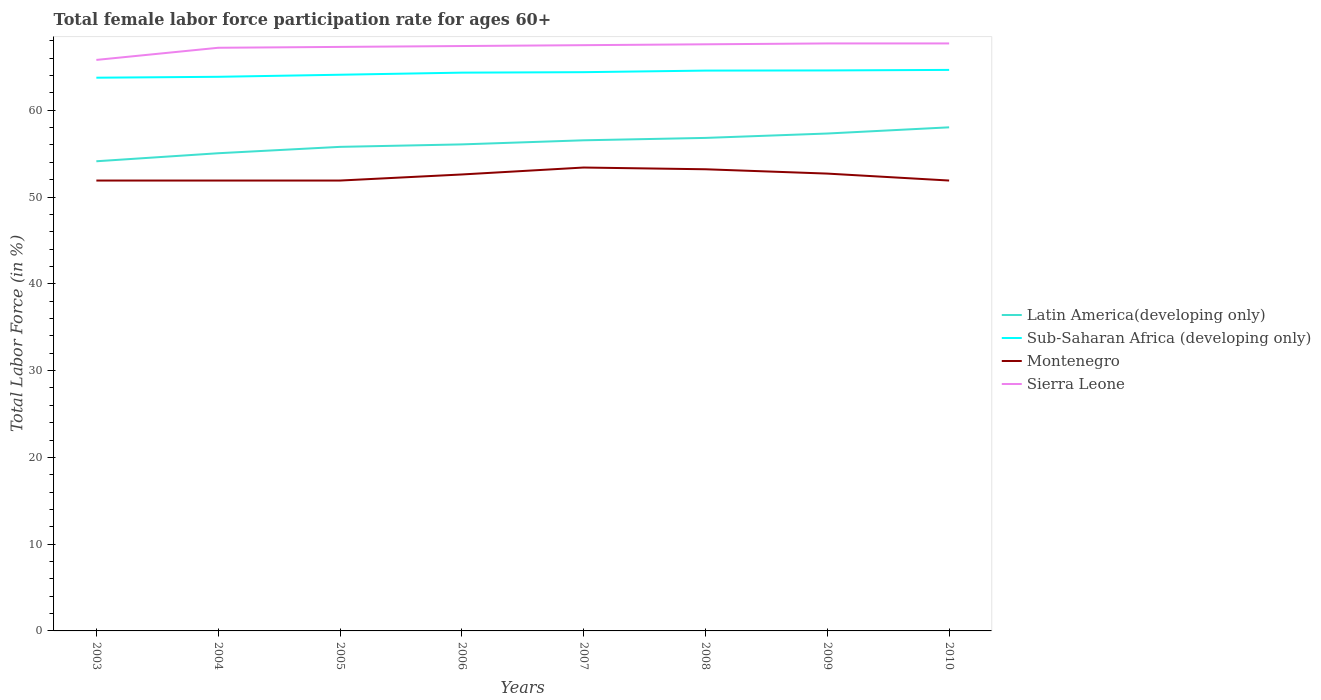How many different coloured lines are there?
Keep it short and to the point. 4. Does the line corresponding to Sierra Leone intersect with the line corresponding to Latin America(developing only)?
Your answer should be very brief. No. Across all years, what is the maximum female labor force participation rate in Latin America(developing only)?
Ensure brevity in your answer.  54.12. In which year was the female labor force participation rate in Montenegro maximum?
Offer a very short reply. 2003. What is the total female labor force participation rate in Latin America(developing only) in the graph?
Provide a short and direct response. -3.2. What is the difference between the highest and the second highest female labor force participation rate in Latin America(developing only)?
Your response must be concise. 3.91. What is the difference between the highest and the lowest female labor force participation rate in Latin America(developing only)?
Make the answer very short. 4. Is the female labor force participation rate in Latin America(developing only) strictly greater than the female labor force participation rate in Montenegro over the years?
Give a very brief answer. No. How many lines are there?
Provide a short and direct response. 4. How many years are there in the graph?
Ensure brevity in your answer.  8. What is the difference between two consecutive major ticks on the Y-axis?
Keep it short and to the point. 10. Where does the legend appear in the graph?
Offer a terse response. Center right. What is the title of the graph?
Provide a succinct answer. Total female labor force participation rate for ages 60+. What is the label or title of the Y-axis?
Keep it short and to the point. Total Labor Force (in %). What is the Total Labor Force (in %) of Latin America(developing only) in 2003?
Offer a terse response. 54.12. What is the Total Labor Force (in %) of Sub-Saharan Africa (developing only) in 2003?
Provide a succinct answer. 63.75. What is the Total Labor Force (in %) of Montenegro in 2003?
Your answer should be very brief. 51.9. What is the Total Labor Force (in %) in Sierra Leone in 2003?
Provide a short and direct response. 65.8. What is the Total Labor Force (in %) in Latin America(developing only) in 2004?
Your answer should be compact. 55.05. What is the Total Labor Force (in %) in Sub-Saharan Africa (developing only) in 2004?
Ensure brevity in your answer.  63.86. What is the Total Labor Force (in %) of Montenegro in 2004?
Your response must be concise. 51.9. What is the Total Labor Force (in %) of Sierra Leone in 2004?
Ensure brevity in your answer.  67.2. What is the Total Labor Force (in %) of Latin America(developing only) in 2005?
Provide a short and direct response. 55.78. What is the Total Labor Force (in %) of Sub-Saharan Africa (developing only) in 2005?
Offer a terse response. 64.09. What is the Total Labor Force (in %) of Montenegro in 2005?
Provide a succinct answer. 51.9. What is the Total Labor Force (in %) of Sierra Leone in 2005?
Ensure brevity in your answer.  67.3. What is the Total Labor Force (in %) in Latin America(developing only) in 2006?
Your answer should be very brief. 56.07. What is the Total Labor Force (in %) of Sub-Saharan Africa (developing only) in 2006?
Provide a short and direct response. 64.33. What is the Total Labor Force (in %) of Montenegro in 2006?
Your response must be concise. 52.6. What is the Total Labor Force (in %) of Sierra Leone in 2006?
Offer a very short reply. 67.4. What is the Total Labor Force (in %) in Latin America(developing only) in 2007?
Provide a succinct answer. 56.54. What is the Total Labor Force (in %) in Sub-Saharan Africa (developing only) in 2007?
Your answer should be very brief. 64.39. What is the Total Labor Force (in %) of Montenegro in 2007?
Give a very brief answer. 53.4. What is the Total Labor Force (in %) in Sierra Leone in 2007?
Your response must be concise. 67.5. What is the Total Labor Force (in %) in Latin America(developing only) in 2008?
Keep it short and to the point. 56.81. What is the Total Labor Force (in %) in Sub-Saharan Africa (developing only) in 2008?
Ensure brevity in your answer.  64.57. What is the Total Labor Force (in %) in Montenegro in 2008?
Ensure brevity in your answer.  53.2. What is the Total Labor Force (in %) in Sierra Leone in 2008?
Give a very brief answer. 67.6. What is the Total Labor Force (in %) in Latin America(developing only) in 2009?
Ensure brevity in your answer.  57.32. What is the Total Labor Force (in %) of Sub-Saharan Africa (developing only) in 2009?
Your answer should be compact. 64.59. What is the Total Labor Force (in %) of Montenegro in 2009?
Provide a short and direct response. 52.7. What is the Total Labor Force (in %) of Sierra Leone in 2009?
Your answer should be compact. 67.7. What is the Total Labor Force (in %) of Latin America(developing only) in 2010?
Make the answer very short. 58.03. What is the Total Labor Force (in %) of Sub-Saharan Africa (developing only) in 2010?
Ensure brevity in your answer.  64.65. What is the Total Labor Force (in %) in Montenegro in 2010?
Ensure brevity in your answer.  51.9. What is the Total Labor Force (in %) in Sierra Leone in 2010?
Your answer should be compact. 67.7. Across all years, what is the maximum Total Labor Force (in %) of Latin America(developing only)?
Provide a succinct answer. 58.03. Across all years, what is the maximum Total Labor Force (in %) in Sub-Saharan Africa (developing only)?
Provide a succinct answer. 64.65. Across all years, what is the maximum Total Labor Force (in %) of Montenegro?
Provide a succinct answer. 53.4. Across all years, what is the maximum Total Labor Force (in %) of Sierra Leone?
Your answer should be very brief. 67.7. Across all years, what is the minimum Total Labor Force (in %) of Latin America(developing only)?
Provide a succinct answer. 54.12. Across all years, what is the minimum Total Labor Force (in %) in Sub-Saharan Africa (developing only)?
Make the answer very short. 63.75. Across all years, what is the minimum Total Labor Force (in %) of Montenegro?
Offer a very short reply. 51.9. Across all years, what is the minimum Total Labor Force (in %) of Sierra Leone?
Provide a succinct answer. 65.8. What is the total Total Labor Force (in %) of Latin America(developing only) in the graph?
Ensure brevity in your answer.  449.71. What is the total Total Labor Force (in %) in Sub-Saharan Africa (developing only) in the graph?
Offer a terse response. 514.23. What is the total Total Labor Force (in %) of Montenegro in the graph?
Ensure brevity in your answer.  419.5. What is the total Total Labor Force (in %) in Sierra Leone in the graph?
Your answer should be very brief. 538.2. What is the difference between the Total Labor Force (in %) of Latin America(developing only) in 2003 and that in 2004?
Your response must be concise. -0.93. What is the difference between the Total Labor Force (in %) of Sub-Saharan Africa (developing only) in 2003 and that in 2004?
Ensure brevity in your answer.  -0.1. What is the difference between the Total Labor Force (in %) of Montenegro in 2003 and that in 2004?
Give a very brief answer. 0. What is the difference between the Total Labor Force (in %) of Latin America(developing only) in 2003 and that in 2005?
Your answer should be very brief. -1.66. What is the difference between the Total Labor Force (in %) in Sub-Saharan Africa (developing only) in 2003 and that in 2005?
Provide a short and direct response. -0.34. What is the difference between the Total Labor Force (in %) in Montenegro in 2003 and that in 2005?
Keep it short and to the point. 0. What is the difference between the Total Labor Force (in %) of Latin America(developing only) in 2003 and that in 2006?
Your answer should be very brief. -1.94. What is the difference between the Total Labor Force (in %) in Sub-Saharan Africa (developing only) in 2003 and that in 2006?
Make the answer very short. -0.58. What is the difference between the Total Labor Force (in %) of Montenegro in 2003 and that in 2006?
Keep it short and to the point. -0.7. What is the difference between the Total Labor Force (in %) in Latin America(developing only) in 2003 and that in 2007?
Offer a very short reply. -2.42. What is the difference between the Total Labor Force (in %) of Sub-Saharan Africa (developing only) in 2003 and that in 2007?
Your response must be concise. -0.64. What is the difference between the Total Labor Force (in %) in Montenegro in 2003 and that in 2007?
Your response must be concise. -1.5. What is the difference between the Total Labor Force (in %) in Latin America(developing only) in 2003 and that in 2008?
Your response must be concise. -2.69. What is the difference between the Total Labor Force (in %) in Sub-Saharan Africa (developing only) in 2003 and that in 2008?
Keep it short and to the point. -0.82. What is the difference between the Total Labor Force (in %) of Sierra Leone in 2003 and that in 2008?
Keep it short and to the point. -1.8. What is the difference between the Total Labor Force (in %) in Latin America(developing only) in 2003 and that in 2009?
Give a very brief answer. -3.2. What is the difference between the Total Labor Force (in %) in Sub-Saharan Africa (developing only) in 2003 and that in 2009?
Keep it short and to the point. -0.84. What is the difference between the Total Labor Force (in %) of Montenegro in 2003 and that in 2009?
Provide a short and direct response. -0.8. What is the difference between the Total Labor Force (in %) in Sierra Leone in 2003 and that in 2009?
Ensure brevity in your answer.  -1.9. What is the difference between the Total Labor Force (in %) of Latin America(developing only) in 2003 and that in 2010?
Provide a short and direct response. -3.91. What is the difference between the Total Labor Force (in %) in Sub-Saharan Africa (developing only) in 2003 and that in 2010?
Your answer should be very brief. -0.9. What is the difference between the Total Labor Force (in %) in Latin America(developing only) in 2004 and that in 2005?
Your answer should be very brief. -0.73. What is the difference between the Total Labor Force (in %) of Sub-Saharan Africa (developing only) in 2004 and that in 2005?
Offer a very short reply. -0.24. What is the difference between the Total Labor Force (in %) of Latin America(developing only) in 2004 and that in 2006?
Make the answer very short. -1.02. What is the difference between the Total Labor Force (in %) of Sub-Saharan Africa (developing only) in 2004 and that in 2006?
Provide a short and direct response. -0.48. What is the difference between the Total Labor Force (in %) in Latin America(developing only) in 2004 and that in 2007?
Ensure brevity in your answer.  -1.49. What is the difference between the Total Labor Force (in %) in Sub-Saharan Africa (developing only) in 2004 and that in 2007?
Your response must be concise. -0.53. What is the difference between the Total Labor Force (in %) in Latin America(developing only) in 2004 and that in 2008?
Your response must be concise. -1.77. What is the difference between the Total Labor Force (in %) of Sub-Saharan Africa (developing only) in 2004 and that in 2008?
Your answer should be very brief. -0.71. What is the difference between the Total Labor Force (in %) in Latin America(developing only) in 2004 and that in 2009?
Provide a succinct answer. -2.27. What is the difference between the Total Labor Force (in %) of Sub-Saharan Africa (developing only) in 2004 and that in 2009?
Give a very brief answer. -0.73. What is the difference between the Total Labor Force (in %) of Montenegro in 2004 and that in 2009?
Keep it short and to the point. -0.8. What is the difference between the Total Labor Force (in %) in Sierra Leone in 2004 and that in 2009?
Your answer should be compact. -0.5. What is the difference between the Total Labor Force (in %) of Latin America(developing only) in 2004 and that in 2010?
Provide a succinct answer. -2.99. What is the difference between the Total Labor Force (in %) in Sub-Saharan Africa (developing only) in 2004 and that in 2010?
Ensure brevity in your answer.  -0.79. What is the difference between the Total Labor Force (in %) of Latin America(developing only) in 2005 and that in 2006?
Provide a short and direct response. -0.28. What is the difference between the Total Labor Force (in %) in Sub-Saharan Africa (developing only) in 2005 and that in 2006?
Your answer should be very brief. -0.24. What is the difference between the Total Labor Force (in %) of Sierra Leone in 2005 and that in 2006?
Provide a succinct answer. -0.1. What is the difference between the Total Labor Force (in %) of Latin America(developing only) in 2005 and that in 2007?
Give a very brief answer. -0.76. What is the difference between the Total Labor Force (in %) in Sub-Saharan Africa (developing only) in 2005 and that in 2007?
Your answer should be compact. -0.3. What is the difference between the Total Labor Force (in %) of Latin America(developing only) in 2005 and that in 2008?
Your answer should be compact. -1.03. What is the difference between the Total Labor Force (in %) of Sub-Saharan Africa (developing only) in 2005 and that in 2008?
Provide a short and direct response. -0.48. What is the difference between the Total Labor Force (in %) in Latin America(developing only) in 2005 and that in 2009?
Keep it short and to the point. -1.54. What is the difference between the Total Labor Force (in %) of Sub-Saharan Africa (developing only) in 2005 and that in 2009?
Provide a succinct answer. -0.49. What is the difference between the Total Labor Force (in %) in Montenegro in 2005 and that in 2009?
Provide a short and direct response. -0.8. What is the difference between the Total Labor Force (in %) in Latin America(developing only) in 2005 and that in 2010?
Provide a short and direct response. -2.25. What is the difference between the Total Labor Force (in %) in Sub-Saharan Africa (developing only) in 2005 and that in 2010?
Your answer should be compact. -0.56. What is the difference between the Total Labor Force (in %) in Sierra Leone in 2005 and that in 2010?
Keep it short and to the point. -0.4. What is the difference between the Total Labor Force (in %) of Latin America(developing only) in 2006 and that in 2007?
Give a very brief answer. -0.47. What is the difference between the Total Labor Force (in %) of Sub-Saharan Africa (developing only) in 2006 and that in 2007?
Your response must be concise. -0.06. What is the difference between the Total Labor Force (in %) of Sierra Leone in 2006 and that in 2007?
Keep it short and to the point. -0.1. What is the difference between the Total Labor Force (in %) of Latin America(developing only) in 2006 and that in 2008?
Your response must be concise. -0.75. What is the difference between the Total Labor Force (in %) of Sub-Saharan Africa (developing only) in 2006 and that in 2008?
Your response must be concise. -0.24. What is the difference between the Total Labor Force (in %) in Montenegro in 2006 and that in 2008?
Keep it short and to the point. -0.6. What is the difference between the Total Labor Force (in %) in Sierra Leone in 2006 and that in 2008?
Provide a short and direct response. -0.2. What is the difference between the Total Labor Force (in %) in Latin America(developing only) in 2006 and that in 2009?
Your answer should be very brief. -1.25. What is the difference between the Total Labor Force (in %) in Sub-Saharan Africa (developing only) in 2006 and that in 2009?
Provide a succinct answer. -0.25. What is the difference between the Total Labor Force (in %) of Montenegro in 2006 and that in 2009?
Your answer should be compact. -0.1. What is the difference between the Total Labor Force (in %) of Latin America(developing only) in 2006 and that in 2010?
Offer a terse response. -1.97. What is the difference between the Total Labor Force (in %) of Sub-Saharan Africa (developing only) in 2006 and that in 2010?
Your response must be concise. -0.32. What is the difference between the Total Labor Force (in %) of Montenegro in 2006 and that in 2010?
Keep it short and to the point. 0.7. What is the difference between the Total Labor Force (in %) in Latin America(developing only) in 2007 and that in 2008?
Offer a terse response. -0.28. What is the difference between the Total Labor Force (in %) in Sub-Saharan Africa (developing only) in 2007 and that in 2008?
Offer a terse response. -0.18. What is the difference between the Total Labor Force (in %) of Sierra Leone in 2007 and that in 2008?
Give a very brief answer. -0.1. What is the difference between the Total Labor Force (in %) in Latin America(developing only) in 2007 and that in 2009?
Give a very brief answer. -0.78. What is the difference between the Total Labor Force (in %) in Sub-Saharan Africa (developing only) in 2007 and that in 2009?
Provide a succinct answer. -0.2. What is the difference between the Total Labor Force (in %) of Montenegro in 2007 and that in 2009?
Provide a succinct answer. 0.7. What is the difference between the Total Labor Force (in %) of Sierra Leone in 2007 and that in 2009?
Your answer should be compact. -0.2. What is the difference between the Total Labor Force (in %) of Latin America(developing only) in 2007 and that in 2010?
Your answer should be compact. -1.49. What is the difference between the Total Labor Force (in %) in Sub-Saharan Africa (developing only) in 2007 and that in 2010?
Your answer should be compact. -0.26. What is the difference between the Total Labor Force (in %) in Montenegro in 2007 and that in 2010?
Your response must be concise. 1.5. What is the difference between the Total Labor Force (in %) in Latin America(developing only) in 2008 and that in 2009?
Your response must be concise. -0.51. What is the difference between the Total Labor Force (in %) in Sub-Saharan Africa (developing only) in 2008 and that in 2009?
Keep it short and to the point. -0.02. What is the difference between the Total Labor Force (in %) of Montenegro in 2008 and that in 2009?
Give a very brief answer. 0.5. What is the difference between the Total Labor Force (in %) of Latin America(developing only) in 2008 and that in 2010?
Provide a succinct answer. -1.22. What is the difference between the Total Labor Force (in %) of Sub-Saharan Africa (developing only) in 2008 and that in 2010?
Offer a terse response. -0.08. What is the difference between the Total Labor Force (in %) of Sierra Leone in 2008 and that in 2010?
Provide a succinct answer. -0.1. What is the difference between the Total Labor Force (in %) in Latin America(developing only) in 2009 and that in 2010?
Make the answer very short. -0.71. What is the difference between the Total Labor Force (in %) in Sub-Saharan Africa (developing only) in 2009 and that in 2010?
Your answer should be compact. -0.06. What is the difference between the Total Labor Force (in %) of Sierra Leone in 2009 and that in 2010?
Give a very brief answer. 0. What is the difference between the Total Labor Force (in %) in Latin America(developing only) in 2003 and the Total Labor Force (in %) in Sub-Saharan Africa (developing only) in 2004?
Give a very brief answer. -9.73. What is the difference between the Total Labor Force (in %) in Latin America(developing only) in 2003 and the Total Labor Force (in %) in Montenegro in 2004?
Ensure brevity in your answer.  2.22. What is the difference between the Total Labor Force (in %) of Latin America(developing only) in 2003 and the Total Labor Force (in %) of Sierra Leone in 2004?
Offer a terse response. -13.08. What is the difference between the Total Labor Force (in %) in Sub-Saharan Africa (developing only) in 2003 and the Total Labor Force (in %) in Montenegro in 2004?
Your answer should be compact. 11.85. What is the difference between the Total Labor Force (in %) of Sub-Saharan Africa (developing only) in 2003 and the Total Labor Force (in %) of Sierra Leone in 2004?
Provide a short and direct response. -3.45. What is the difference between the Total Labor Force (in %) of Montenegro in 2003 and the Total Labor Force (in %) of Sierra Leone in 2004?
Provide a short and direct response. -15.3. What is the difference between the Total Labor Force (in %) in Latin America(developing only) in 2003 and the Total Labor Force (in %) in Sub-Saharan Africa (developing only) in 2005?
Your answer should be compact. -9.97. What is the difference between the Total Labor Force (in %) of Latin America(developing only) in 2003 and the Total Labor Force (in %) of Montenegro in 2005?
Make the answer very short. 2.22. What is the difference between the Total Labor Force (in %) in Latin America(developing only) in 2003 and the Total Labor Force (in %) in Sierra Leone in 2005?
Your answer should be very brief. -13.18. What is the difference between the Total Labor Force (in %) of Sub-Saharan Africa (developing only) in 2003 and the Total Labor Force (in %) of Montenegro in 2005?
Your answer should be compact. 11.85. What is the difference between the Total Labor Force (in %) in Sub-Saharan Africa (developing only) in 2003 and the Total Labor Force (in %) in Sierra Leone in 2005?
Make the answer very short. -3.55. What is the difference between the Total Labor Force (in %) of Montenegro in 2003 and the Total Labor Force (in %) of Sierra Leone in 2005?
Ensure brevity in your answer.  -15.4. What is the difference between the Total Labor Force (in %) of Latin America(developing only) in 2003 and the Total Labor Force (in %) of Sub-Saharan Africa (developing only) in 2006?
Make the answer very short. -10.21. What is the difference between the Total Labor Force (in %) of Latin America(developing only) in 2003 and the Total Labor Force (in %) of Montenegro in 2006?
Offer a very short reply. 1.52. What is the difference between the Total Labor Force (in %) in Latin America(developing only) in 2003 and the Total Labor Force (in %) in Sierra Leone in 2006?
Offer a terse response. -13.28. What is the difference between the Total Labor Force (in %) in Sub-Saharan Africa (developing only) in 2003 and the Total Labor Force (in %) in Montenegro in 2006?
Your answer should be compact. 11.15. What is the difference between the Total Labor Force (in %) in Sub-Saharan Africa (developing only) in 2003 and the Total Labor Force (in %) in Sierra Leone in 2006?
Ensure brevity in your answer.  -3.65. What is the difference between the Total Labor Force (in %) in Montenegro in 2003 and the Total Labor Force (in %) in Sierra Leone in 2006?
Make the answer very short. -15.5. What is the difference between the Total Labor Force (in %) of Latin America(developing only) in 2003 and the Total Labor Force (in %) of Sub-Saharan Africa (developing only) in 2007?
Offer a terse response. -10.27. What is the difference between the Total Labor Force (in %) in Latin America(developing only) in 2003 and the Total Labor Force (in %) in Montenegro in 2007?
Your answer should be very brief. 0.72. What is the difference between the Total Labor Force (in %) of Latin America(developing only) in 2003 and the Total Labor Force (in %) of Sierra Leone in 2007?
Make the answer very short. -13.38. What is the difference between the Total Labor Force (in %) in Sub-Saharan Africa (developing only) in 2003 and the Total Labor Force (in %) in Montenegro in 2007?
Your answer should be very brief. 10.35. What is the difference between the Total Labor Force (in %) of Sub-Saharan Africa (developing only) in 2003 and the Total Labor Force (in %) of Sierra Leone in 2007?
Offer a terse response. -3.75. What is the difference between the Total Labor Force (in %) of Montenegro in 2003 and the Total Labor Force (in %) of Sierra Leone in 2007?
Your answer should be compact. -15.6. What is the difference between the Total Labor Force (in %) in Latin America(developing only) in 2003 and the Total Labor Force (in %) in Sub-Saharan Africa (developing only) in 2008?
Your answer should be compact. -10.45. What is the difference between the Total Labor Force (in %) in Latin America(developing only) in 2003 and the Total Labor Force (in %) in Montenegro in 2008?
Keep it short and to the point. 0.92. What is the difference between the Total Labor Force (in %) in Latin America(developing only) in 2003 and the Total Labor Force (in %) in Sierra Leone in 2008?
Your response must be concise. -13.48. What is the difference between the Total Labor Force (in %) of Sub-Saharan Africa (developing only) in 2003 and the Total Labor Force (in %) of Montenegro in 2008?
Make the answer very short. 10.55. What is the difference between the Total Labor Force (in %) in Sub-Saharan Africa (developing only) in 2003 and the Total Labor Force (in %) in Sierra Leone in 2008?
Your response must be concise. -3.85. What is the difference between the Total Labor Force (in %) in Montenegro in 2003 and the Total Labor Force (in %) in Sierra Leone in 2008?
Provide a succinct answer. -15.7. What is the difference between the Total Labor Force (in %) in Latin America(developing only) in 2003 and the Total Labor Force (in %) in Sub-Saharan Africa (developing only) in 2009?
Offer a terse response. -10.47. What is the difference between the Total Labor Force (in %) in Latin America(developing only) in 2003 and the Total Labor Force (in %) in Montenegro in 2009?
Offer a terse response. 1.42. What is the difference between the Total Labor Force (in %) of Latin America(developing only) in 2003 and the Total Labor Force (in %) of Sierra Leone in 2009?
Your response must be concise. -13.58. What is the difference between the Total Labor Force (in %) in Sub-Saharan Africa (developing only) in 2003 and the Total Labor Force (in %) in Montenegro in 2009?
Make the answer very short. 11.05. What is the difference between the Total Labor Force (in %) of Sub-Saharan Africa (developing only) in 2003 and the Total Labor Force (in %) of Sierra Leone in 2009?
Keep it short and to the point. -3.95. What is the difference between the Total Labor Force (in %) in Montenegro in 2003 and the Total Labor Force (in %) in Sierra Leone in 2009?
Make the answer very short. -15.8. What is the difference between the Total Labor Force (in %) of Latin America(developing only) in 2003 and the Total Labor Force (in %) of Sub-Saharan Africa (developing only) in 2010?
Make the answer very short. -10.53. What is the difference between the Total Labor Force (in %) in Latin America(developing only) in 2003 and the Total Labor Force (in %) in Montenegro in 2010?
Your answer should be very brief. 2.22. What is the difference between the Total Labor Force (in %) of Latin America(developing only) in 2003 and the Total Labor Force (in %) of Sierra Leone in 2010?
Offer a terse response. -13.58. What is the difference between the Total Labor Force (in %) of Sub-Saharan Africa (developing only) in 2003 and the Total Labor Force (in %) of Montenegro in 2010?
Keep it short and to the point. 11.85. What is the difference between the Total Labor Force (in %) in Sub-Saharan Africa (developing only) in 2003 and the Total Labor Force (in %) in Sierra Leone in 2010?
Offer a terse response. -3.95. What is the difference between the Total Labor Force (in %) in Montenegro in 2003 and the Total Labor Force (in %) in Sierra Leone in 2010?
Make the answer very short. -15.8. What is the difference between the Total Labor Force (in %) in Latin America(developing only) in 2004 and the Total Labor Force (in %) in Sub-Saharan Africa (developing only) in 2005?
Your response must be concise. -9.05. What is the difference between the Total Labor Force (in %) in Latin America(developing only) in 2004 and the Total Labor Force (in %) in Montenegro in 2005?
Give a very brief answer. 3.15. What is the difference between the Total Labor Force (in %) in Latin America(developing only) in 2004 and the Total Labor Force (in %) in Sierra Leone in 2005?
Your response must be concise. -12.25. What is the difference between the Total Labor Force (in %) of Sub-Saharan Africa (developing only) in 2004 and the Total Labor Force (in %) of Montenegro in 2005?
Offer a terse response. 11.96. What is the difference between the Total Labor Force (in %) in Sub-Saharan Africa (developing only) in 2004 and the Total Labor Force (in %) in Sierra Leone in 2005?
Ensure brevity in your answer.  -3.44. What is the difference between the Total Labor Force (in %) in Montenegro in 2004 and the Total Labor Force (in %) in Sierra Leone in 2005?
Make the answer very short. -15.4. What is the difference between the Total Labor Force (in %) in Latin America(developing only) in 2004 and the Total Labor Force (in %) in Sub-Saharan Africa (developing only) in 2006?
Your response must be concise. -9.29. What is the difference between the Total Labor Force (in %) in Latin America(developing only) in 2004 and the Total Labor Force (in %) in Montenegro in 2006?
Make the answer very short. 2.45. What is the difference between the Total Labor Force (in %) of Latin America(developing only) in 2004 and the Total Labor Force (in %) of Sierra Leone in 2006?
Provide a short and direct response. -12.35. What is the difference between the Total Labor Force (in %) in Sub-Saharan Africa (developing only) in 2004 and the Total Labor Force (in %) in Montenegro in 2006?
Make the answer very short. 11.26. What is the difference between the Total Labor Force (in %) of Sub-Saharan Africa (developing only) in 2004 and the Total Labor Force (in %) of Sierra Leone in 2006?
Provide a short and direct response. -3.54. What is the difference between the Total Labor Force (in %) in Montenegro in 2004 and the Total Labor Force (in %) in Sierra Leone in 2006?
Provide a succinct answer. -15.5. What is the difference between the Total Labor Force (in %) of Latin America(developing only) in 2004 and the Total Labor Force (in %) of Sub-Saharan Africa (developing only) in 2007?
Your answer should be very brief. -9.34. What is the difference between the Total Labor Force (in %) of Latin America(developing only) in 2004 and the Total Labor Force (in %) of Montenegro in 2007?
Your response must be concise. 1.65. What is the difference between the Total Labor Force (in %) in Latin America(developing only) in 2004 and the Total Labor Force (in %) in Sierra Leone in 2007?
Your answer should be very brief. -12.45. What is the difference between the Total Labor Force (in %) in Sub-Saharan Africa (developing only) in 2004 and the Total Labor Force (in %) in Montenegro in 2007?
Give a very brief answer. 10.46. What is the difference between the Total Labor Force (in %) of Sub-Saharan Africa (developing only) in 2004 and the Total Labor Force (in %) of Sierra Leone in 2007?
Give a very brief answer. -3.64. What is the difference between the Total Labor Force (in %) of Montenegro in 2004 and the Total Labor Force (in %) of Sierra Leone in 2007?
Provide a short and direct response. -15.6. What is the difference between the Total Labor Force (in %) of Latin America(developing only) in 2004 and the Total Labor Force (in %) of Sub-Saharan Africa (developing only) in 2008?
Make the answer very short. -9.52. What is the difference between the Total Labor Force (in %) of Latin America(developing only) in 2004 and the Total Labor Force (in %) of Montenegro in 2008?
Keep it short and to the point. 1.85. What is the difference between the Total Labor Force (in %) in Latin America(developing only) in 2004 and the Total Labor Force (in %) in Sierra Leone in 2008?
Ensure brevity in your answer.  -12.55. What is the difference between the Total Labor Force (in %) in Sub-Saharan Africa (developing only) in 2004 and the Total Labor Force (in %) in Montenegro in 2008?
Keep it short and to the point. 10.66. What is the difference between the Total Labor Force (in %) of Sub-Saharan Africa (developing only) in 2004 and the Total Labor Force (in %) of Sierra Leone in 2008?
Ensure brevity in your answer.  -3.74. What is the difference between the Total Labor Force (in %) in Montenegro in 2004 and the Total Labor Force (in %) in Sierra Leone in 2008?
Keep it short and to the point. -15.7. What is the difference between the Total Labor Force (in %) in Latin America(developing only) in 2004 and the Total Labor Force (in %) in Sub-Saharan Africa (developing only) in 2009?
Offer a terse response. -9.54. What is the difference between the Total Labor Force (in %) in Latin America(developing only) in 2004 and the Total Labor Force (in %) in Montenegro in 2009?
Offer a terse response. 2.35. What is the difference between the Total Labor Force (in %) in Latin America(developing only) in 2004 and the Total Labor Force (in %) in Sierra Leone in 2009?
Ensure brevity in your answer.  -12.65. What is the difference between the Total Labor Force (in %) in Sub-Saharan Africa (developing only) in 2004 and the Total Labor Force (in %) in Montenegro in 2009?
Provide a short and direct response. 11.16. What is the difference between the Total Labor Force (in %) of Sub-Saharan Africa (developing only) in 2004 and the Total Labor Force (in %) of Sierra Leone in 2009?
Keep it short and to the point. -3.84. What is the difference between the Total Labor Force (in %) of Montenegro in 2004 and the Total Labor Force (in %) of Sierra Leone in 2009?
Offer a terse response. -15.8. What is the difference between the Total Labor Force (in %) in Latin America(developing only) in 2004 and the Total Labor Force (in %) in Sub-Saharan Africa (developing only) in 2010?
Make the answer very short. -9.6. What is the difference between the Total Labor Force (in %) of Latin America(developing only) in 2004 and the Total Labor Force (in %) of Montenegro in 2010?
Provide a succinct answer. 3.15. What is the difference between the Total Labor Force (in %) of Latin America(developing only) in 2004 and the Total Labor Force (in %) of Sierra Leone in 2010?
Your response must be concise. -12.65. What is the difference between the Total Labor Force (in %) in Sub-Saharan Africa (developing only) in 2004 and the Total Labor Force (in %) in Montenegro in 2010?
Make the answer very short. 11.96. What is the difference between the Total Labor Force (in %) of Sub-Saharan Africa (developing only) in 2004 and the Total Labor Force (in %) of Sierra Leone in 2010?
Your answer should be very brief. -3.84. What is the difference between the Total Labor Force (in %) of Montenegro in 2004 and the Total Labor Force (in %) of Sierra Leone in 2010?
Give a very brief answer. -15.8. What is the difference between the Total Labor Force (in %) of Latin America(developing only) in 2005 and the Total Labor Force (in %) of Sub-Saharan Africa (developing only) in 2006?
Your answer should be compact. -8.55. What is the difference between the Total Labor Force (in %) of Latin America(developing only) in 2005 and the Total Labor Force (in %) of Montenegro in 2006?
Provide a succinct answer. 3.18. What is the difference between the Total Labor Force (in %) in Latin America(developing only) in 2005 and the Total Labor Force (in %) in Sierra Leone in 2006?
Your response must be concise. -11.62. What is the difference between the Total Labor Force (in %) of Sub-Saharan Africa (developing only) in 2005 and the Total Labor Force (in %) of Montenegro in 2006?
Your answer should be compact. 11.49. What is the difference between the Total Labor Force (in %) of Sub-Saharan Africa (developing only) in 2005 and the Total Labor Force (in %) of Sierra Leone in 2006?
Ensure brevity in your answer.  -3.31. What is the difference between the Total Labor Force (in %) in Montenegro in 2005 and the Total Labor Force (in %) in Sierra Leone in 2006?
Offer a terse response. -15.5. What is the difference between the Total Labor Force (in %) of Latin America(developing only) in 2005 and the Total Labor Force (in %) of Sub-Saharan Africa (developing only) in 2007?
Keep it short and to the point. -8.61. What is the difference between the Total Labor Force (in %) of Latin America(developing only) in 2005 and the Total Labor Force (in %) of Montenegro in 2007?
Give a very brief answer. 2.38. What is the difference between the Total Labor Force (in %) of Latin America(developing only) in 2005 and the Total Labor Force (in %) of Sierra Leone in 2007?
Give a very brief answer. -11.72. What is the difference between the Total Labor Force (in %) of Sub-Saharan Africa (developing only) in 2005 and the Total Labor Force (in %) of Montenegro in 2007?
Your answer should be compact. 10.69. What is the difference between the Total Labor Force (in %) in Sub-Saharan Africa (developing only) in 2005 and the Total Labor Force (in %) in Sierra Leone in 2007?
Ensure brevity in your answer.  -3.41. What is the difference between the Total Labor Force (in %) of Montenegro in 2005 and the Total Labor Force (in %) of Sierra Leone in 2007?
Keep it short and to the point. -15.6. What is the difference between the Total Labor Force (in %) in Latin America(developing only) in 2005 and the Total Labor Force (in %) in Sub-Saharan Africa (developing only) in 2008?
Provide a short and direct response. -8.79. What is the difference between the Total Labor Force (in %) in Latin America(developing only) in 2005 and the Total Labor Force (in %) in Montenegro in 2008?
Provide a succinct answer. 2.58. What is the difference between the Total Labor Force (in %) of Latin America(developing only) in 2005 and the Total Labor Force (in %) of Sierra Leone in 2008?
Ensure brevity in your answer.  -11.82. What is the difference between the Total Labor Force (in %) in Sub-Saharan Africa (developing only) in 2005 and the Total Labor Force (in %) in Montenegro in 2008?
Ensure brevity in your answer.  10.89. What is the difference between the Total Labor Force (in %) in Sub-Saharan Africa (developing only) in 2005 and the Total Labor Force (in %) in Sierra Leone in 2008?
Your answer should be very brief. -3.51. What is the difference between the Total Labor Force (in %) of Montenegro in 2005 and the Total Labor Force (in %) of Sierra Leone in 2008?
Make the answer very short. -15.7. What is the difference between the Total Labor Force (in %) of Latin America(developing only) in 2005 and the Total Labor Force (in %) of Sub-Saharan Africa (developing only) in 2009?
Provide a succinct answer. -8.81. What is the difference between the Total Labor Force (in %) of Latin America(developing only) in 2005 and the Total Labor Force (in %) of Montenegro in 2009?
Provide a succinct answer. 3.08. What is the difference between the Total Labor Force (in %) in Latin America(developing only) in 2005 and the Total Labor Force (in %) in Sierra Leone in 2009?
Your answer should be compact. -11.92. What is the difference between the Total Labor Force (in %) in Sub-Saharan Africa (developing only) in 2005 and the Total Labor Force (in %) in Montenegro in 2009?
Provide a short and direct response. 11.39. What is the difference between the Total Labor Force (in %) of Sub-Saharan Africa (developing only) in 2005 and the Total Labor Force (in %) of Sierra Leone in 2009?
Your answer should be compact. -3.61. What is the difference between the Total Labor Force (in %) in Montenegro in 2005 and the Total Labor Force (in %) in Sierra Leone in 2009?
Give a very brief answer. -15.8. What is the difference between the Total Labor Force (in %) of Latin America(developing only) in 2005 and the Total Labor Force (in %) of Sub-Saharan Africa (developing only) in 2010?
Your answer should be compact. -8.87. What is the difference between the Total Labor Force (in %) of Latin America(developing only) in 2005 and the Total Labor Force (in %) of Montenegro in 2010?
Give a very brief answer. 3.88. What is the difference between the Total Labor Force (in %) in Latin America(developing only) in 2005 and the Total Labor Force (in %) in Sierra Leone in 2010?
Your response must be concise. -11.92. What is the difference between the Total Labor Force (in %) in Sub-Saharan Africa (developing only) in 2005 and the Total Labor Force (in %) in Montenegro in 2010?
Make the answer very short. 12.19. What is the difference between the Total Labor Force (in %) of Sub-Saharan Africa (developing only) in 2005 and the Total Labor Force (in %) of Sierra Leone in 2010?
Your answer should be very brief. -3.61. What is the difference between the Total Labor Force (in %) of Montenegro in 2005 and the Total Labor Force (in %) of Sierra Leone in 2010?
Ensure brevity in your answer.  -15.8. What is the difference between the Total Labor Force (in %) of Latin America(developing only) in 2006 and the Total Labor Force (in %) of Sub-Saharan Africa (developing only) in 2007?
Provide a succinct answer. -8.32. What is the difference between the Total Labor Force (in %) in Latin America(developing only) in 2006 and the Total Labor Force (in %) in Montenegro in 2007?
Your answer should be very brief. 2.67. What is the difference between the Total Labor Force (in %) of Latin America(developing only) in 2006 and the Total Labor Force (in %) of Sierra Leone in 2007?
Offer a terse response. -11.43. What is the difference between the Total Labor Force (in %) of Sub-Saharan Africa (developing only) in 2006 and the Total Labor Force (in %) of Montenegro in 2007?
Keep it short and to the point. 10.93. What is the difference between the Total Labor Force (in %) in Sub-Saharan Africa (developing only) in 2006 and the Total Labor Force (in %) in Sierra Leone in 2007?
Make the answer very short. -3.17. What is the difference between the Total Labor Force (in %) in Montenegro in 2006 and the Total Labor Force (in %) in Sierra Leone in 2007?
Give a very brief answer. -14.9. What is the difference between the Total Labor Force (in %) of Latin America(developing only) in 2006 and the Total Labor Force (in %) of Sub-Saharan Africa (developing only) in 2008?
Give a very brief answer. -8.5. What is the difference between the Total Labor Force (in %) of Latin America(developing only) in 2006 and the Total Labor Force (in %) of Montenegro in 2008?
Offer a very short reply. 2.87. What is the difference between the Total Labor Force (in %) in Latin America(developing only) in 2006 and the Total Labor Force (in %) in Sierra Leone in 2008?
Give a very brief answer. -11.53. What is the difference between the Total Labor Force (in %) in Sub-Saharan Africa (developing only) in 2006 and the Total Labor Force (in %) in Montenegro in 2008?
Give a very brief answer. 11.13. What is the difference between the Total Labor Force (in %) of Sub-Saharan Africa (developing only) in 2006 and the Total Labor Force (in %) of Sierra Leone in 2008?
Provide a short and direct response. -3.27. What is the difference between the Total Labor Force (in %) in Latin America(developing only) in 2006 and the Total Labor Force (in %) in Sub-Saharan Africa (developing only) in 2009?
Provide a short and direct response. -8.52. What is the difference between the Total Labor Force (in %) of Latin America(developing only) in 2006 and the Total Labor Force (in %) of Montenegro in 2009?
Give a very brief answer. 3.37. What is the difference between the Total Labor Force (in %) in Latin America(developing only) in 2006 and the Total Labor Force (in %) in Sierra Leone in 2009?
Give a very brief answer. -11.63. What is the difference between the Total Labor Force (in %) of Sub-Saharan Africa (developing only) in 2006 and the Total Labor Force (in %) of Montenegro in 2009?
Make the answer very short. 11.63. What is the difference between the Total Labor Force (in %) in Sub-Saharan Africa (developing only) in 2006 and the Total Labor Force (in %) in Sierra Leone in 2009?
Offer a very short reply. -3.37. What is the difference between the Total Labor Force (in %) of Montenegro in 2006 and the Total Labor Force (in %) of Sierra Leone in 2009?
Provide a succinct answer. -15.1. What is the difference between the Total Labor Force (in %) of Latin America(developing only) in 2006 and the Total Labor Force (in %) of Sub-Saharan Africa (developing only) in 2010?
Keep it short and to the point. -8.58. What is the difference between the Total Labor Force (in %) of Latin America(developing only) in 2006 and the Total Labor Force (in %) of Montenegro in 2010?
Offer a terse response. 4.17. What is the difference between the Total Labor Force (in %) of Latin America(developing only) in 2006 and the Total Labor Force (in %) of Sierra Leone in 2010?
Make the answer very short. -11.63. What is the difference between the Total Labor Force (in %) in Sub-Saharan Africa (developing only) in 2006 and the Total Labor Force (in %) in Montenegro in 2010?
Your response must be concise. 12.43. What is the difference between the Total Labor Force (in %) in Sub-Saharan Africa (developing only) in 2006 and the Total Labor Force (in %) in Sierra Leone in 2010?
Give a very brief answer. -3.37. What is the difference between the Total Labor Force (in %) of Montenegro in 2006 and the Total Labor Force (in %) of Sierra Leone in 2010?
Give a very brief answer. -15.1. What is the difference between the Total Labor Force (in %) in Latin America(developing only) in 2007 and the Total Labor Force (in %) in Sub-Saharan Africa (developing only) in 2008?
Offer a terse response. -8.03. What is the difference between the Total Labor Force (in %) in Latin America(developing only) in 2007 and the Total Labor Force (in %) in Montenegro in 2008?
Your answer should be very brief. 3.34. What is the difference between the Total Labor Force (in %) in Latin America(developing only) in 2007 and the Total Labor Force (in %) in Sierra Leone in 2008?
Provide a short and direct response. -11.06. What is the difference between the Total Labor Force (in %) of Sub-Saharan Africa (developing only) in 2007 and the Total Labor Force (in %) of Montenegro in 2008?
Keep it short and to the point. 11.19. What is the difference between the Total Labor Force (in %) of Sub-Saharan Africa (developing only) in 2007 and the Total Labor Force (in %) of Sierra Leone in 2008?
Provide a short and direct response. -3.21. What is the difference between the Total Labor Force (in %) of Latin America(developing only) in 2007 and the Total Labor Force (in %) of Sub-Saharan Africa (developing only) in 2009?
Keep it short and to the point. -8.05. What is the difference between the Total Labor Force (in %) in Latin America(developing only) in 2007 and the Total Labor Force (in %) in Montenegro in 2009?
Your answer should be very brief. 3.84. What is the difference between the Total Labor Force (in %) in Latin America(developing only) in 2007 and the Total Labor Force (in %) in Sierra Leone in 2009?
Your answer should be very brief. -11.16. What is the difference between the Total Labor Force (in %) of Sub-Saharan Africa (developing only) in 2007 and the Total Labor Force (in %) of Montenegro in 2009?
Ensure brevity in your answer.  11.69. What is the difference between the Total Labor Force (in %) of Sub-Saharan Africa (developing only) in 2007 and the Total Labor Force (in %) of Sierra Leone in 2009?
Give a very brief answer. -3.31. What is the difference between the Total Labor Force (in %) in Montenegro in 2007 and the Total Labor Force (in %) in Sierra Leone in 2009?
Give a very brief answer. -14.3. What is the difference between the Total Labor Force (in %) in Latin America(developing only) in 2007 and the Total Labor Force (in %) in Sub-Saharan Africa (developing only) in 2010?
Provide a short and direct response. -8.11. What is the difference between the Total Labor Force (in %) of Latin America(developing only) in 2007 and the Total Labor Force (in %) of Montenegro in 2010?
Your answer should be compact. 4.64. What is the difference between the Total Labor Force (in %) of Latin America(developing only) in 2007 and the Total Labor Force (in %) of Sierra Leone in 2010?
Keep it short and to the point. -11.16. What is the difference between the Total Labor Force (in %) of Sub-Saharan Africa (developing only) in 2007 and the Total Labor Force (in %) of Montenegro in 2010?
Provide a short and direct response. 12.49. What is the difference between the Total Labor Force (in %) of Sub-Saharan Africa (developing only) in 2007 and the Total Labor Force (in %) of Sierra Leone in 2010?
Give a very brief answer. -3.31. What is the difference between the Total Labor Force (in %) in Montenegro in 2007 and the Total Labor Force (in %) in Sierra Leone in 2010?
Your answer should be compact. -14.3. What is the difference between the Total Labor Force (in %) in Latin America(developing only) in 2008 and the Total Labor Force (in %) in Sub-Saharan Africa (developing only) in 2009?
Your answer should be compact. -7.77. What is the difference between the Total Labor Force (in %) in Latin America(developing only) in 2008 and the Total Labor Force (in %) in Montenegro in 2009?
Your answer should be very brief. 4.11. What is the difference between the Total Labor Force (in %) of Latin America(developing only) in 2008 and the Total Labor Force (in %) of Sierra Leone in 2009?
Keep it short and to the point. -10.89. What is the difference between the Total Labor Force (in %) of Sub-Saharan Africa (developing only) in 2008 and the Total Labor Force (in %) of Montenegro in 2009?
Give a very brief answer. 11.87. What is the difference between the Total Labor Force (in %) in Sub-Saharan Africa (developing only) in 2008 and the Total Labor Force (in %) in Sierra Leone in 2009?
Keep it short and to the point. -3.13. What is the difference between the Total Labor Force (in %) in Montenegro in 2008 and the Total Labor Force (in %) in Sierra Leone in 2009?
Your answer should be very brief. -14.5. What is the difference between the Total Labor Force (in %) of Latin America(developing only) in 2008 and the Total Labor Force (in %) of Sub-Saharan Africa (developing only) in 2010?
Give a very brief answer. -7.84. What is the difference between the Total Labor Force (in %) in Latin America(developing only) in 2008 and the Total Labor Force (in %) in Montenegro in 2010?
Your response must be concise. 4.91. What is the difference between the Total Labor Force (in %) of Latin America(developing only) in 2008 and the Total Labor Force (in %) of Sierra Leone in 2010?
Offer a very short reply. -10.89. What is the difference between the Total Labor Force (in %) in Sub-Saharan Africa (developing only) in 2008 and the Total Labor Force (in %) in Montenegro in 2010?
Provide a short and direct response. 12.67. What is the difference between the Total Labor Force (in %) of Sub-Saharan Africa (developing only) in 2008 and the Total Labor Force (in %) of Sierra Leone in 2010?
Provide a succinct answer. -3.13. What is the difference between the Total Labor Force (in %) in Latin America(developing only) in 2009 and the Total Labor Force (in %) in Sub-Saharan Africa (developing only) in 2010?
Keep it short and to the point. -7.33. What is the difference between the Total Labor Force (in %) in Latin America(developing only) in 2009 and the Total Labor Force (in %) in Montenegro in 2010?
Keep it short and to the point. 5.42. What is the difference between the Total Labor Force (in %) of Latin America(developing only) in 2009 and the Total Labor Force (in %) of Sierra Leone in 2010?
Your answer should be very brief. -10.38. What is the difference between the Total Labor Force (in %) in Sub-Saharan Africa (developing only) in 2009 and the Total Labor Force (in %) in Montenegro in 2010?
Make the answer very short. 12.69. What is the difference between the Total Labor Force (in %) in Sub-Saharan Africa (developing only) in 2009 and the Total Labor Force (in %) in Sierra Leone in 2010?
Your response must be concise. -3.11. What is the average Total Labor Force (in %) in Latin America(developing only) per year?
Ensure brevity in your answer.  56.21. What is the average Total Labor Force (in %) in Sub-Saharan Africa (developing only) per year?
Provide a succinct answer. 64.28. What is the average Total Labor Force (in %) of Montenegro per year?
Offer a terse response. 52.44. What is the average Total Labor Force (in %) in Sierra Leone per year?
Keep it short and to the point. 67.28. In the year 2003, what is the difference between the Total Labor Force (in %) of Latin America(developing only) and Total Labor Force (in %) of Sub-Saharan Africa (developing only)?
Offer a very short reply. -9.63. In the year 2003, what is the difference between the Total Labor Force (in %) in Latin America(developing only) and Total Labor Force (in %) in Montenegro?
Provide a short and direct response. 2.22. In the year 2003, what is the difference between the Total Labor Force (in %) of Latin America(developing only) and Total Labor Force (in %) of Sierra Leone?
Provide a succinct answer. -11.68. In the year 2003, what is the difference between the Total Labor Force (in %) in Sub-Saharan Africa (developing only) and Total Labor Force (in %) in Montenegro?
Your answer should be compact. 11.85. In the year 2003, what is the difference between the Total Labor Force (in %) in Sub-Saharan Africa (developing only) and Total Labor Force (in %) in Sierra Leone?
Your response must be concise. -2.05. In the year 2004, what is the difference between the Total Labor Force (in %) of Latin America(developing only) and Total Labor Force (in %) of Sub-Saharan Africa (developing only)?
Your answer should be compact. -8.81. In the year 2004, what is the difference between the Total Labor Force (in %) of Latin America(developing only) and Total Labor Force (in %) of Montenegro?
Make the answer very short. 3.15. In the year 2004, what is the difference between the Total Labor Force (in %) of Latin America(developing only) and Total Labor Force (in %) of Sierra Leone?
Your response must be concise. -12.15. In the year 2004, what is the difference between the Total Labor Force (in %) in Sub-Saharan Africa (developing only) and Total Labor Force (in %) in Montenegro?
Your answer should be very brief. 11.96. In the year 2004, what is the difference between the Total Labor Force (in %) in Sub-Saharan Africa (developing only) and Total Labor Force (in %) in Sierra Leone?
Keep it short and to the point. -3.34. In the year 2004, what is the difference between the Total Labor Force (in %) in Montenegro and Total Labor Force (in %) in Sierra Leone?
Make the answer very short. -15.3. In the year 2005, what is the difference between the Total Labor Force (in %) in Latin America(developing only) and Total Labor Force (in %) in Sub-Saharan Africa (developing only)?
Ensure brevity in your answer.  -8.31. In the year 2005, what is the difference between the Total Labor Force (in %) of Latin America(developing only) and Total Labor Force (in %) of Montenegro?
Make the answer very short. 3.88. In the year 2005, what is the difference between the Total Labor Force (in %) in Latin America(developing only) and Total Labor Force (in %) in Sierra Leone?
Your response must be concise. -11.52. In the year 2005, what is the difference between the Total Labor Force (in %) of Sub-Saharan Africa (developing only) and Total Labor Force (in %) of Montenegro?
Your answer should be very brief. 12.19. In the year 2005, what is the difference between the Total Labor Force (in %) of Sub-Saharan Africa (developing only) and Total Labor Force (in %) of Sierra Leone?
Your answer should be compact. -3.21. In the year 2005, what is the difference between the Total Labor Force (in %) in Montenegro and Total Labor Force (in %) in Sierra Leone?
Your answer should be compact. -15.4. In the year 2006, what is the difference between the Total Labor Force (in %) in Latin America(developing only) and Total Labor Force (in %) in Sub-Saharan Africa (developing only)?
Your answer should be very brief. -8.27. In the year 2006, what is the difference between the Total Labor Force (in %) of Latin America(developing only) and Total Labor Force (in %) of Montenegro?
Provide a short and direct response. 3.47. In the year 2006, what is the difference between the Total Labor Force (in %) of Latin America(developing only) and Total Labor Force (in %) of Sierra Leone?
Provide a short and direct response. -11.33. In the year 2006, what is the difference between the Total Labor Force (in %) of Sub-Saharan Africa (developing only) and Total Labor Force (in %) of Montenegro?
Your answer should be compact. 11.73. In the year 2006, what is the difference between the Total Labor Force (in %) in Sub-Saharan Africa (developing only) and Total Labor Force (in %) in Sierra Leone?
Provide a succinct answer. -3.07. In the year 2006, what is the difference between the Total Labor Force (in %) of Montenegro and Total Labor Force (in %) of Sierra Leone?
Make the answer very short. -14.8. In the year 2007, what is the difference between the Total Labor Force (in %) in Latin America(developing only) and Total Labor Force (in %) in Sub-Saharan Africa (developing only)?
Offer a very short reply. -7.85. In the year 2007, what is the difference between the Total Labor Force (in %) in Latin America(developing only) and Total Labor Force (in %) in Montenegro?
Offer a terse response. 3.14. In the year 2007, what is the difference between the Total Labor Force (in %) in Latin America(developing only) and Total Labor Force (in %) in Sierra Leone?
Keep it short and to the point. -10.96. In the year 2007, what is the difference between the Total Labor Force (in %) in Sub-Saharan Africa (developing only) and Total Labor Force (in %) in Montenegro?
Ensure brevity in your answer.  10.99. In the year 2007, what is the difference between the Total Labor Force (in %) in Sub-Saharan Africa (developing only) and Total Labor Force (in %) in Sierra Leone?
Your response must be concise. -3.11. In the year 2007, what is the difference between the Total Labor Force (in %) in Montenegro and Total Labor Force (in %) in Sierra Leone?
Keep it short and to the point. -14.1. In the year 2008, what is the difference between the Total Labor Force (in %) of Latin America(developing only) and Total Labor Force (in %) of Sub-Saharan Africa (developing only)?
Keep it short and to the point. -7.76. In the year 2008, what is the difference between the Total Labor Force (in %) in Latin America(developing only) and Total Labor Force (in %) in Montenegro?
Your answer should be very brief. 3.61. In the year 2008, what is the difference between the Total Labor Force (in %) in Latin America(developing only) and Total Labor Force (in %) in Sierra Leone?
Provide a short and direct response. -10.79. In the year 2008, what is the difference between the Total Labor Force (in %) of Sub-Saharan Africa (developing only) and Total Labor Force (in %) of Montenegro?
Offer a very short reply. 11.37. In the year 2008, what is the difference between the Total Labor Force (in %) in Sub-Saharan Africa (developing only) and Total Labor Force (in %) in Sierra Leone?
Offer a very short reply. -3.03. In the year 2008, what is the difference between the Total Labor Force (in %) of Montenegro and Total Labor Force (in %) of Sierra Leone?
Give a very brief answer. -14.4. In the year 2009, what is the difference between the Total Labor Force (in %) of Latin America(developing only) and Total Labor Force (in %) of Sub-Saharan Africa (developing only)?
Make the answer very short. -7.27. In the year 2009, what is the difference between the Total Labor Force (in %) in Latin America(developing only) and Total Labor Force (in %) in Montenegro?
Ensure brevity in your answer.  4.62. In the year 2009, what is the difference between the Total Labor Force (in %) of Latin America(developing only) and Total Labor Force (in %) of Sierra Leone?
Make the answer very short. -10.38. In the year 2009, what is the difference between the Total Labor Force (in %) in Sub-Saharan Africa (developing only) and Total Labor Force (in %) in Montenegro?
Offer a terse response. 11.89. In the year 2009, what is the difference between the Total Labor Force (in %) of Sub-Saharan Africa (developing only) and Total Labor Force (in %) of Sierra Leone?
Ensure brevity in your answer.  -3.11. In the year 2010, what is the difference between the Total Labor Force (in %) of Latin America(developing only) and Total Labor Force (in %) of Sub-Saharan Africa (developing only)?
Provide a succinct answer. -6.62. In the year 2010, what is the difference between the Total Labor Force (in %) in Latin America(developing only) and Total Labor Force (in %) in Montenegro?
Make the answer very short. 6.13. In the year 2010, what is the difference between the Total Labor Force (in %) in Latin America(developing only) and Total Labor Force (in %) in Sierra Leone?
Give a very brief answer. -9.67. In the year 2010, what is the difference between the Total Labor Force (in %) in Sub-Saharan Africa (developing only) and Total Labor Force (in %) in Montenegro?
Offer a very short reply. 12.75. In the year 2010, what is the difference between the Total Labor Force (in %) of Sub-Saharan Africa (developing only) and Total Labor Force (in %) of Sierra Leone?
Offer a very short reply. -3.05. In the year 2010, what is the difference between the Total Labor Force (in %) in Montenegro and Total Labor Force (in %) in Sierra Leone?
Give a very brief answer. -15.8. What is the ratio of the Total Labor Force (in %) in Latin America(developing only) in 2003 to that in 2004?
Make the answer very short. 0.98. What is the ratio of the Total Labor Force (in %) in Sub-Saharan Africa (developing only) in 2003 to that in 2004?
Ensure brevity in your answer.  1. What is the ratio of the Total Labor Force (in %) of Sierra Leone in 2003 to that in 2004?
Keep it short and to the point. 0.98. What is the ratio of the Total Labor Force (in %) of Latin America(developing only) in 2003 to that in 2005?
Ensure brevity in your answer.  0.97. What is the ratio of the Total Labor Force (in %) of Sub-Saharan Africa (developing only) in 2003 to that in 2005?
Your answer should be very brief. 0.99. What is the ratio of the Total Labor Force (in %) of Montenegro in 2003 to that in 2005?
Offer a terse response. 1. What is the ratio of the Total Labor Force (in %) in Sierra Leone in 2003 to that in 2005?
Keep it short and to the point. 0.98. What is the ratio of the Total Labor Force (in %) of Latin America(developing only) in 2003 to that in 2006?
Make the answer very short. 0.97. What is the ratio of the Total Labor Force (in %) in Montenegro in 2003 to that in 2006?
Make the answer very short. 0.99. What is the ratio of the Total Labor Force (in %) of Sierra Leone in 2003 to that in 2006?
Provide a succinct answer. 0.98. What is the ratio of the Total Labor Force (in %) of Latin America(developing only) in 2003 to that in 2007?
Give a very brief answer. 0.96. What is the ratio of the Total Labor Force (in %) of Sub-Saharan Africa (developing only) in 2003 to that in 2007?
Give a very brief answer. 0.99. What is the ratio of the Total Labor Force (in %) in Montenegro in 2003 to that in 2007?
Offer a terse response. 0.97. What is the ratio of the Total Labor Force (in %) in Sierra Leone in 2003 to that in 2007?
Provide a succinct answer. 0.97. What is the ratio of the Total Labor Force (in %) of Latin America(developing only) in 2003 to that in 2008?
Provide a short and direct response. 0.95. What is the ratio of the Total Labor Force (in %) of Sub-Saharan Africa (developing only) in 2003 to that in 2008?
Make the answer very short. 0.99. What is the ratio of the Total Labor Force (in %) of Montenegro in 2003 to that in 2008?
Give a very brief answer. 0.98. What is the ratio of the Total Labor Force (in %) in Sierra Leone in 2003 to that in 2008?
Offer a terse response. 0.97. What is the ratio of the Total Labor Force (in %) in Latin America(developing only) in 2003 to that in 2009?
Provide a short and direct response. 0.94. What is the ratio of the Total Labor Force (in %) of Sub-Saharan Africa (developing only) in 2003 to that in 2009?
Offer a very short reply. 0.99. What is the ratio of the Total Labor Force (in %) of Montenegro in 2003 to that in 2009?
Your response must be concise. 0.98. What is the ratio of the Total Labor Force (in %) of Sierra Leone in 2003 to that in 2009?
Ensure brevity in your answer.  0.97. What is the ratio of the Total Labor Force (in %) of Latin America(developing only) in 2003 to that in 2010?
Your response must be concise. 0.93. What is the ratio of the Total Labor Force (in %) of Sub-Saharan Africa (developing only) in 2003 to that in 2010?
Provide a succinct answer. 0.99. What is the ratio of the Total Labor Force (in %) in Montenegro in 2003 to that in 2010?
Offer a very short reply. 1. What is the ratio of the Total Labor Force (in %) of Sierra Leone in 2003 to that in 2010?
Provide a succinct answer. 0.97. What is the ratio of the Total Labor Force (in %) in Latin America(developing only) in 2004 to that in 2005?
Give a very brief answer. 0.99. What is the ratio of the Total Labor Force (in %) in Sierra Leone in 2004 to that in 2005?
Keep it short and to the point. 1. What is the ratio of the Total Labor Force (in %) in Latin America(developing only) in 2004 to that in 2006?
Keep it short and to the point. 0.98. What is the ratio of the Total Labor Force (in %) of Montenegro in 2004 to that in 2006?
Your response must be concise. 0.99. What is the ratio of the Total Labor Force (in %) of Latin America(developing only) in 2004 to that in 2007?
Ensure brevity in your answer.  0.97. What is the ratio of the Total Labor Force (in %) of Montenegro in 2004 to that in 2007?
Provide a succinct answer. 0.97. What is the ratio of the Total Labor Force (in %) in Sierra Leone in 2004 to that in 2007?
Your answer should be very brief. 1. What is the ratio of the Total Labor Force (in %) in Latin America(developing only) in 2004 to that in 2008?
Your answer should be compact. 0.97. What is the ratio of the Total Labor Force (in %) of Sub-Saharan Africa (developing only) in 2004 to that in 2008?
Give a very brief answer. 0.99. What is the ratio of the Total Labor Force (in %) of Montenegro in 2004 to that in 2008?
Ensure brevity in your answer.  0.98. What is the ratio of the Total Labor Force (in %) of Sierra Leone in 2004 to that in 2008?
Provide a short and direct response. 0.99. What is the ratio of the Total Labor Force (in %) of Latin America(developing only) in 2004 to that in 2009?
Your answer should be compact. 0.96. What is the ratio of the Total Labor Force (in %) of Sub-Saharan Africa (developing only) in 2004 to that in 2009?
Your answer should be very brief. 0.99. What is the ratio of the Total Labor Force (in %) of Montenegro in 2004 to that in 2009?
Provide a succinct answer. 0.98. What is the ratio of the Total Labor Force (in %) of Sierra Leone in 2004 to that in 2009?
Your response must be concise. 0.99. What is the ratio of the Total Labor Force (in %) in Latin America(developing only) in 2004 to that in 2010?
Ensure brevity in your answer.  0.95. What is the ratio of the Total Labor Force (in %) of Sub-Saharan Africa (developing only) in 2004 to that in 2010?
Offer a terse response. 0.99. What is the ratio of the Total Labor Force (in %) of Montenegro in 2004 to that in 2010?
Give a very brief answer. 1. What is the ratio of the Total Labor Force (in %) in Sierra Leone in 2004 to that in 2010?
Keep it short and to the point. 0.99. What is the ratio of the Total Labor Force (in %) of Latin America(developing only) in 2005 to that in 2006?
Give a very brief answer. 0.99. What is the ratio of the Total Labor Force (in %) in Sub-Saharan Africa (developing only) in 2005 to that in 2006?
Ensure brevity in your answer.  1. What is the ratio of the Total Labor Force (in %) in Montenegro in 2005 to that in 2006?
Provide a short and direct response. 0.99. What is the ratio of the Total Labor Force (in %) in Latin America(developing only) in 2005 to that in 2007?
Offer a terse response. 0.99. What is the ratio of the Total Labor Force (in %) in Sub-Saharan Africa (developing only) in 2005 to that in 2007?
Keep it short and to the point. 1. What is the ratio of the Total Labor Force (in %) in Montenegro in 2005 to that in 2007?
Provide a short and direct response. 0.97. What is the ratio of the Total Labor Force (in %) in Sierra Leone in 2005 to that in 2007?
Offer a terse response. 1. What is the ratio of the Total Labor Force (in %) in Latin America(developing only) in 2005 to that in 2008?
Make the answer very short. 0.98. What is the ratio of the Total Labor Force (in %) of Montenegro in 2005 to that in 2008?
Your response must be concise. 0.98. What is the ratio of the Total Labor Force (in %) in Sierra Leone in 2005 to that in 2008?
Keep it short and to the point. 1. What is the ratio of the Total Labor Force (in %) of Latin America(developing only) in 2005 to that in 2009?
Give a very brief answer. 0.97. What is the ratio of the Total Labor Force (in %) of Sub-Saharan Africa (developing only) in 2005 to that in 2009?
Offer a very short reply. 0.99. What is the ratio of the Total Labor Force (in %) of Montenegro in 2005 to that in 2009?
Provide a succinct answer. 0.98. What is the ratio of the Total Labor Force (in %) in Latin America(developing only) in 2005 to that in 2010?
Give a very brief answer. 0.96. What is the ratio of the Total Labor Force (in %) of Sub-Saharan Africa (developing only) in 2005 to that in 2010?
Provide a short and direct response. 0.99. What is the ratio of the Total Labor Force (in %) in Montenegro in 2005 to that in 2010?
Your response must be concise. 1. What is the ratio of the Total Labor Force (in %) in Sierra Leone in 2005 to that in 2010?
Offer a very short reply. 0.99. What is the ratio of the Total Labor Force (in %) in Sierra Leone in 2006 to that in 2007?
Your answer should be compact. 1. What is the ratio of the Total Labor Force (in %) of Montenegro in 2006 to that in 2008?
Your response must be concise. 0.99. What is the ratio of the Total Labor Force (in %) in Sierra Leone in 2006 to that in 2008?
Provide a short and direct response. 1. What is the ratio of the Total Labor Force (in %) in Latin America(developing only) in 2006 to that in 2009?
Keep it short and to the point. 0.98. What is the ratio of the Total Labor Force (in %) in Sierra Leone in 2006 to that in 2009?
Your answer should be compact. 1. What is the ratio of the Total Labor Force (in %) in Latin America(developing only) in 2006 to that in 2010?
Offer a terse response. 0.97. What is the ratio of the Total Labor Force (in %) in Montenegro in 2006 to that in 2010?
Your answer should be very brief. 1.01. What is the ratio of the Total Labor Force (in %) in Sierra Leone in 2006 to that in 2010?
Your answer should be compact. 1. What is the ratio of the Total Labor Force (in %) of Sub-Saharan Africa (developing only) in 2007 to that in 2008?
Offer a terse response. 1. What is the ratio of the Total Labor Force (in %) in Montenegro in 2007 to that in 2008?
Your answer should be very brief. 1. What is the ratio of the Total Labor Force (in %) in Latin America(developing only) in 2007 to that in 2009?
Make the answer very short. 0.99. What is the ratio of the Total Labor Force (in %) of Montenegro in 2007 to that in 2009?
Your answer should be compact. 1.01. What is the ratio of the Total Labor Force (in %) of Latin America(developing only) in 2007 to that in 2010?
Give a very brief answer. 0.97. What is the ratio of the Total Labor Force (in %) of Sub-Saharan Africa (developing only) in 2007 to that in 2010?
Give a very brief answer. 1. What is the ratio of the Total Labor Force (in %) in Montenegro in 2007 to that in 2010?
Your answer should be compact. 1.03. What is the ratio of the Total Labor Force (in %) of Latin America(developing only) in 2008 to that in 2009?
Ensure brevity in your answer.  0.99. What is the ratio of the Total Labor Force (in %) in Sub-Saharan Africa (developing only) in 2008 to that in 2009?
Keep it short and to the point. 1. What is the ratio of the Total Labor Force (in %) of Montenegro in 2008 to that in 2009?
Ensure brevity in your answer.  1.01. What is the ratio of the Total Labor Force (in %) of Latin America(developing only) in 2008 to that in 2010?
Ensure brevity in your answer.  0.98. What is the ratio of the Total Labor Force (in %) of Sub-Saharan Africa (developing only) in 2008 to that in 2010?
Your answer should be very brief. 1. What is the ratio of the Total Labor Force (in %) in Montenegro in 2008 to that in 2010?
Keep it short and to the point. 1.02. What is the ratio of the Total Labor Force (in %) of Sub-Saharan Africa (developing only) in 2009 to that in 2010?
Keep it short and to the point. 1. What is the ratio of the Total Labor Force (in %) in Montenegro in 2009 to that in 2010?
Ensure brevity in your answer.  1.02. What is the difference between the highest and the second highest Total Labor Force (in %) in Latin America(developing only)?
Offer a terse response. 0.71. What is the difference between the highest and the second highest Total Labor Force (in %) in Sub-Saharan Africa (developing only)?
Ensure brevity in your answer.  0.06. What is the difference between the highest and the second highest Total Labor Force (in %) in Sierra Leone?
Offer a very short reply. 0. What is the difference between the highest and the lowest Total Labor Force (in %) of Latin America(developing only)?
Give a very brief answer. 3.91. What is the difference between the highest and the lowest Total Labor Force (in %) of Sub-Saharan Africa (developing only)?
Ensure brevity in your answer.  0.9. What is the difference between the highest and the lowest Total Labor Force (in %) in Montenegro?
Offer a very short reply. 1.5. What is the difference between the highest and the lowest Total Labor Force (in %) in Sierra Leone?
Your response must be concise. 1.9. 